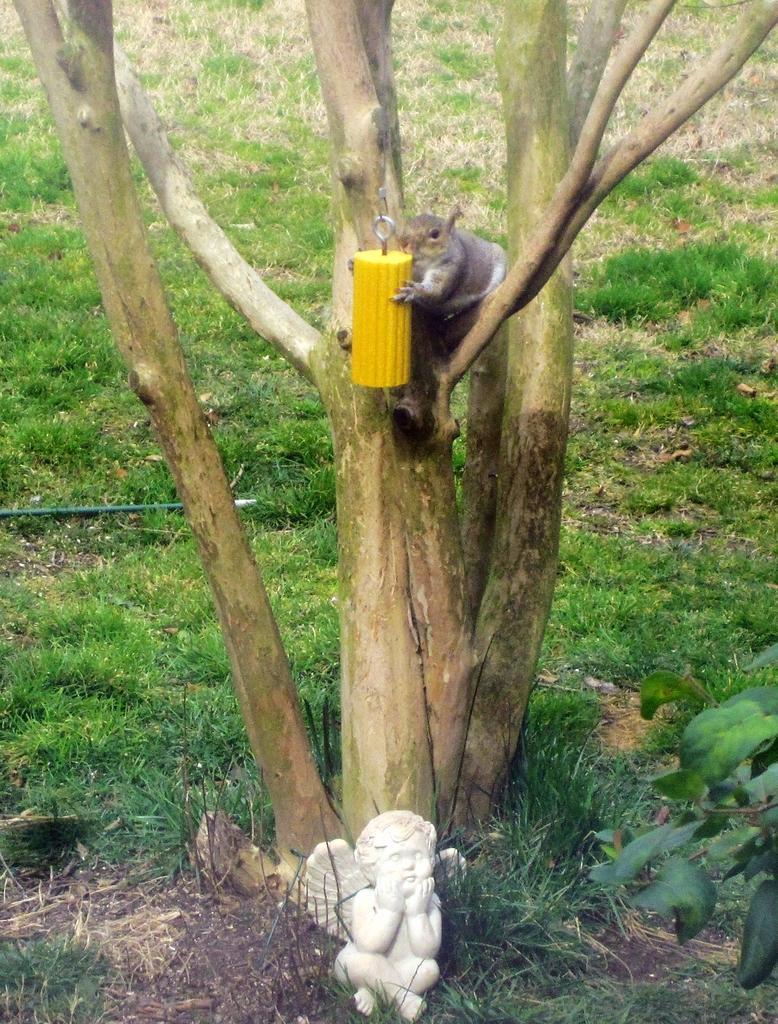In one or two sentences, can you explain what this image depicts? In this image we can see a tree and squirrel is sitting on tree by holding a yellow color thing. Bottom of the image one sculpture is there. Background grass is present on the land. 